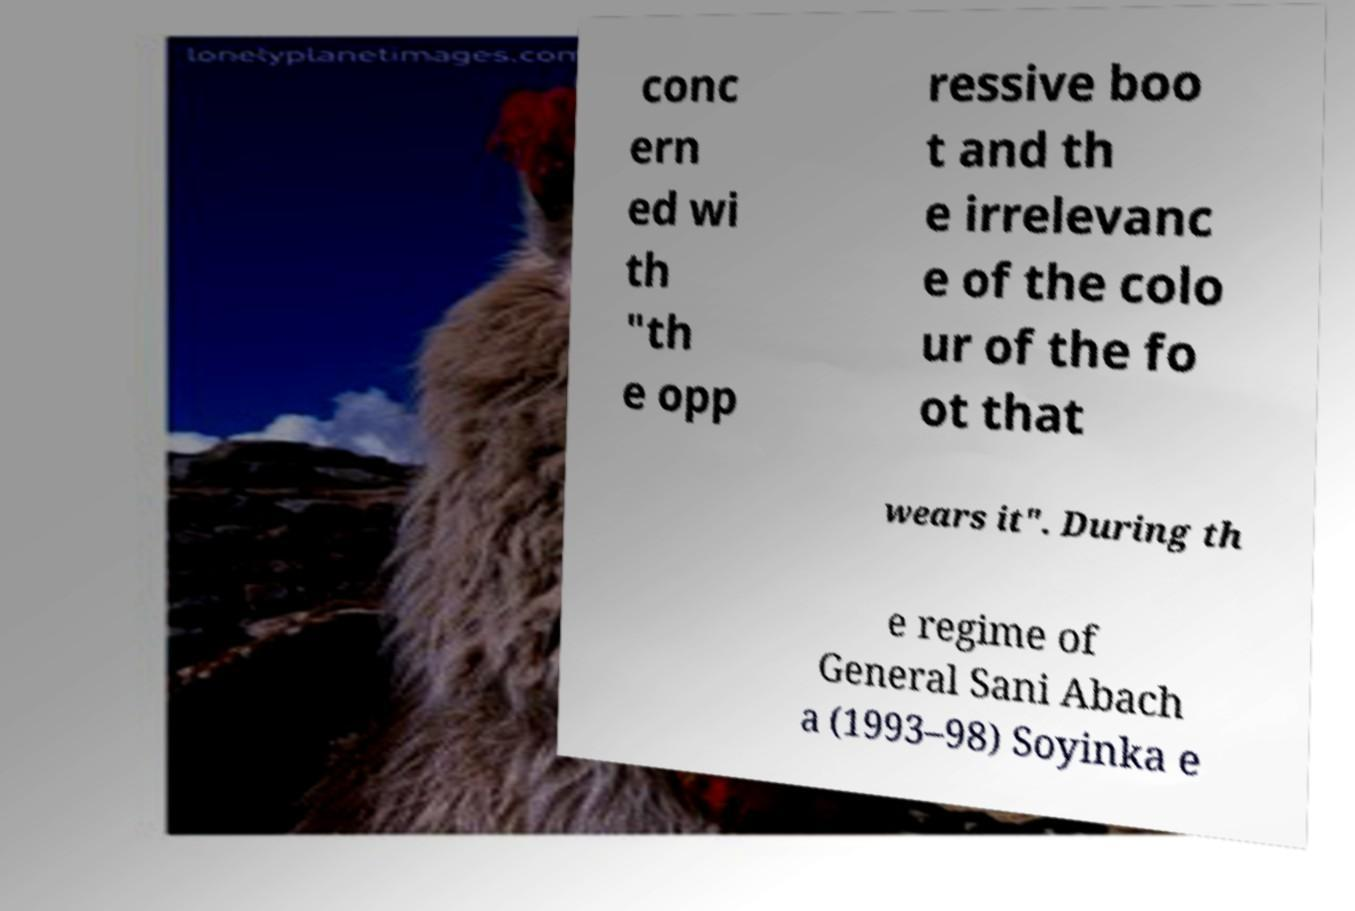Please identify and transcribe the text found in this image. conc ern ed wi th "th e opp ressive boo t and th e irrelevanc e of the colo ur of the fo ot that wears it". During th e regime of General Sani Abach a (1993–98) Soyinka e 